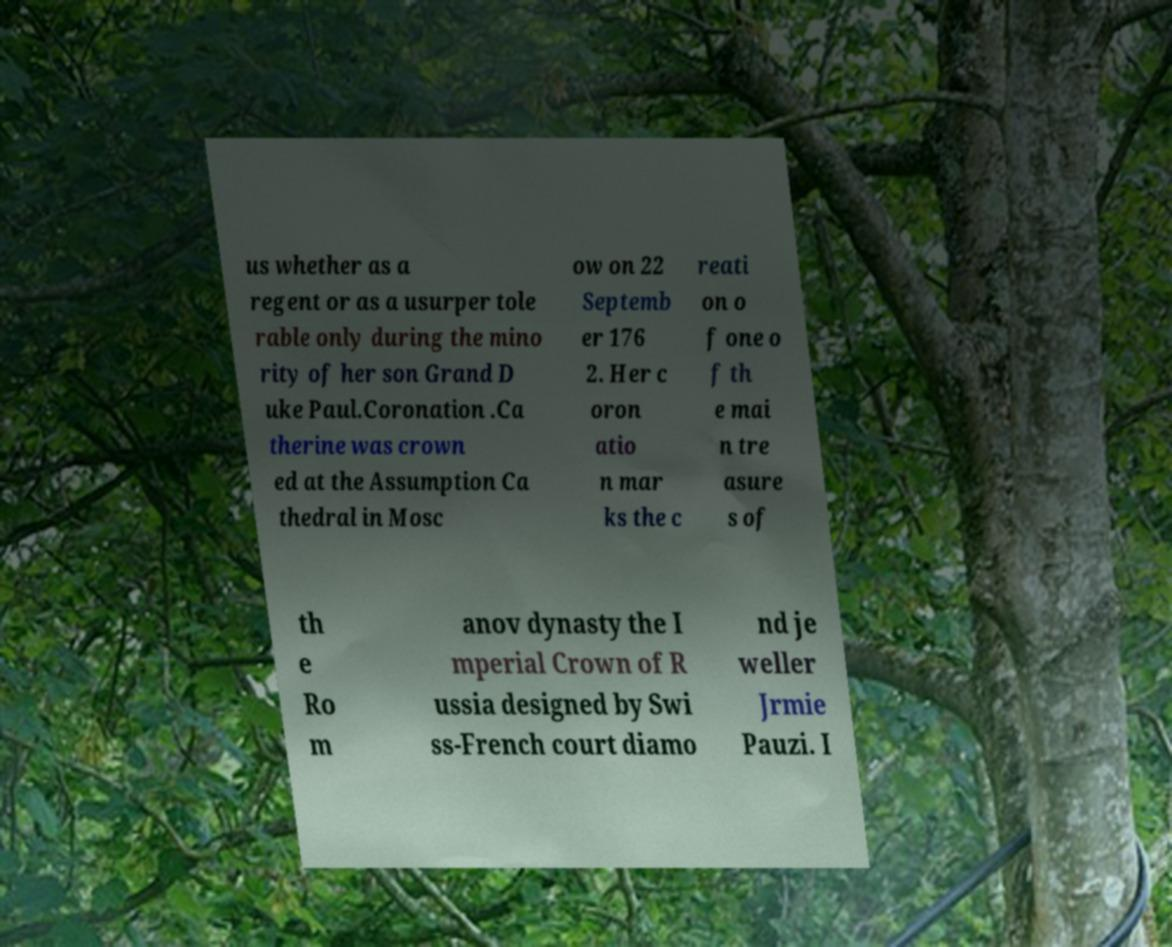For documentation purposes, I need the text within this image transcribed. Could you provide that? us whether as a regent or as a usurper tole rable only during the mino rity of her son Grand D uke Paul.Coronation .Ca therine was crown ed at the Assumption Ca thedral in Mosc ow on 22 Septemb er 176 2. Her c oron atio n mar ks the c reati on o f one o f th e mai n tre asure s of th e Ro m anov dynasty the I mperial Crown of R ussia designed by Swi ss-French court diamo nd je weller Jrmie Pauzi. I 